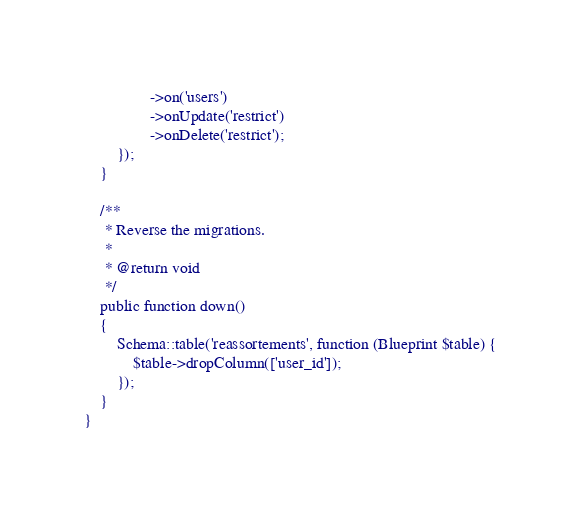<code> <loc_0><loc_0><loc_500><loc_500><_PHP_>                ->on('users')
                ->onUpdate('restrict')
                ->onDelete('restrict');
        });
    }

    /**
     * Reverse the migrations.
     *
     * @return void
     */
    public function down()
    {
        Schema::table('reassortements', function (Blueprint $table) {
            $table->dropColumn(['user_id']);
        });
    }
}
</code> 